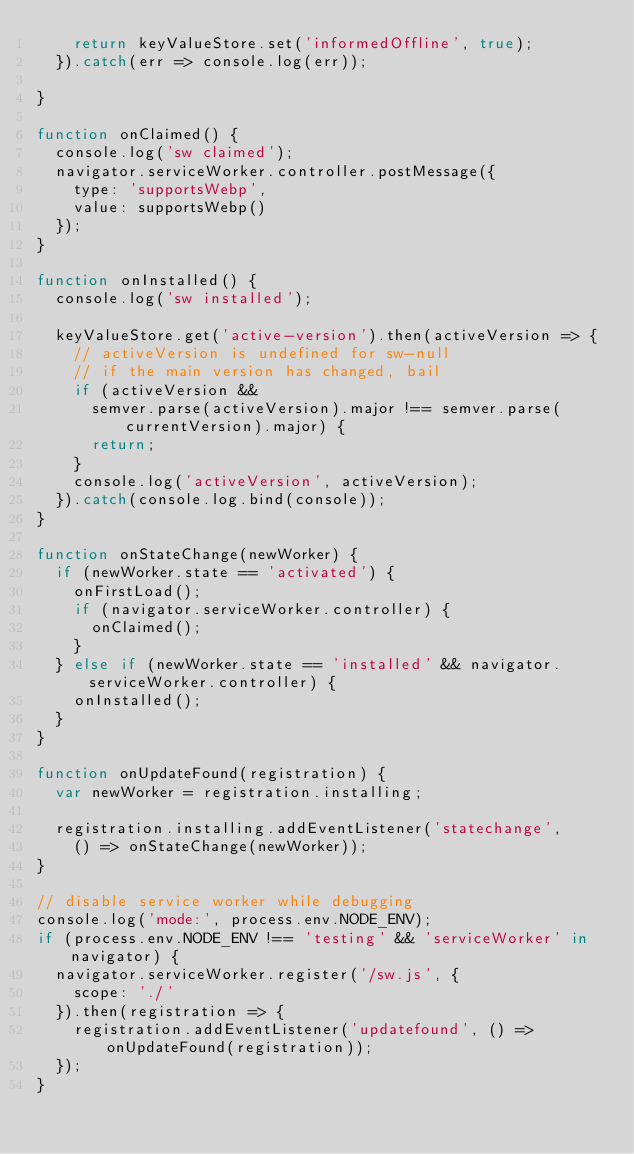<code> <loc_0><loc_0><loc_500><loc_500><_JavaScript_>    return keyValueStore.set('informedOffline', true);
  }).catch(err => console.log(err));

}

function onClaimed() {
  console.log('sw claimed');
  navigator.serviceWorker.controller.postMessage({
    type: 'supportsWebp',
    value: supportsWebp()
  });
}

function onInstalled() {
  console.log('sw installed');

  keyValueStore.get('active-version').then(activeVersion => {
    // activeVersion is undefined for sw-null
    // if the main version has changed, bail
    if (activeVersion &&
      semver.parse(activeVersion).major !== semver.parse(currentVersion).major) {
      return;
    }
    console.log('activeVersion', activeVersion);
  }).catch(console.log.bind(console));
}

function onStateChange(newWorker) {
  if (newWorker.state == 'activated') {
    onFirstLoad();
    if (navigator.serviceWorker.controller) {
      onClaimed();
    }
  } else if (newWorker.state == 'installed' && navigator.serviceWorker.controller) {
    onInstalled();
  }
}

function onUpdateFound(registration) {
  var newWorker = registration.installing;

  registration.installing.addEventListener('statechange',
    () => onStateChange(newWorker));
}

// disable service worker while debugging
console.log('mode:', process.env.NODE_ENV);
if (process.env.NODE_ENV !== 'testing' && 'serviceWorker' in navigator) {
  navigator.serviceWorker.register('/sw.js', {
    scope: './'
  }).then(registration => {
    registration.addEventListener('updatefound', () => onUpdateFound(registration));
  });
}</code> 